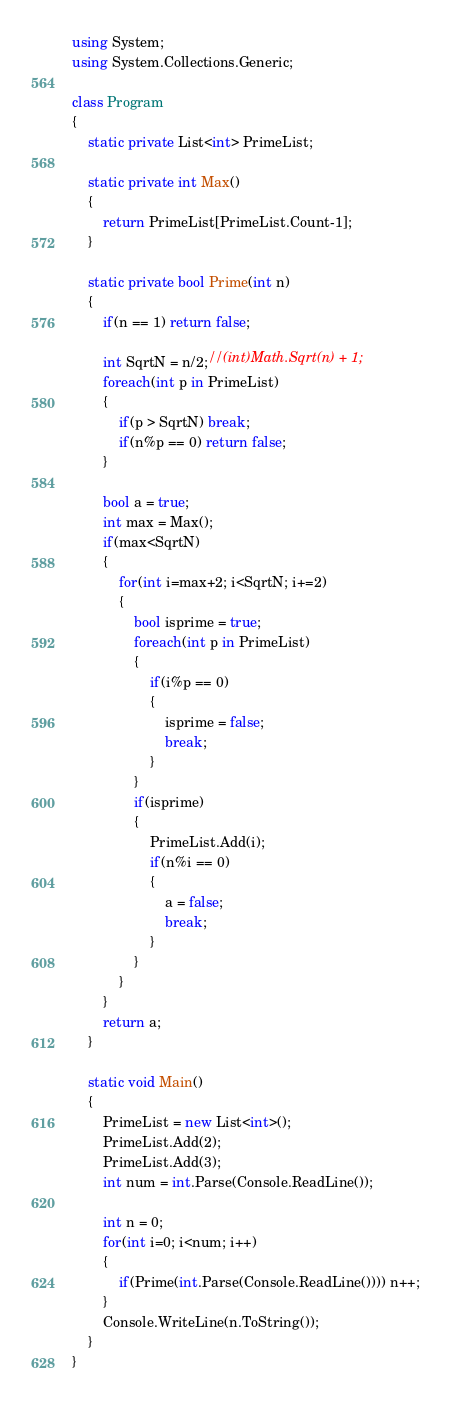<code> <loc_0><loc_0><loc_500><loc_500><_C#_>using System;
using System.Collections.Generic;

class Program
{
	static private List<int> PrimeList;

	static private int Max()
	{
		return PrimeList[PrimeList.Count-1];
	}

	static private bool Prime(int n)
	{
		if(n == 1) return false;

		int SqrtN = n/2;//(int)Math.Sqrt(n) + 1;
		foreach(int p in PrimeList)
		{
			if(p > SqrtN) break;
			if(n%p == 0) return false;
		}

		bool a = true;
		int max = Max();
		if(max<SqrtN)
		{
			for(int i=max+2; i<SqrtN; i+=2)
			{
				bool isprime = true;
				foreach(int p in PrimeList)
				{
					if(i%p == 0)
					{
						isprime = false;
						break;
					}
				}
				if(isprime)
				{
					PrimeList.Add(i);
					if(n%i == 0)
					{
						a = false;
						break;
					}
				}
			}
		}
		return a;
	}

	static void Main() 
	{
		PrimeList = new List<int>();
		PrimeList.Add(2);
		PrimeList.Add(3);
		int num = int.Parse(Console.ReadLine());

		int n = 0;
		for(int i=0; i<num; i++)
		{
			if(Prime(int.Parse(Console.ReadLine()))) n++;
		}
		Console.WriteLine(n.ToString());
	}
}</code> 